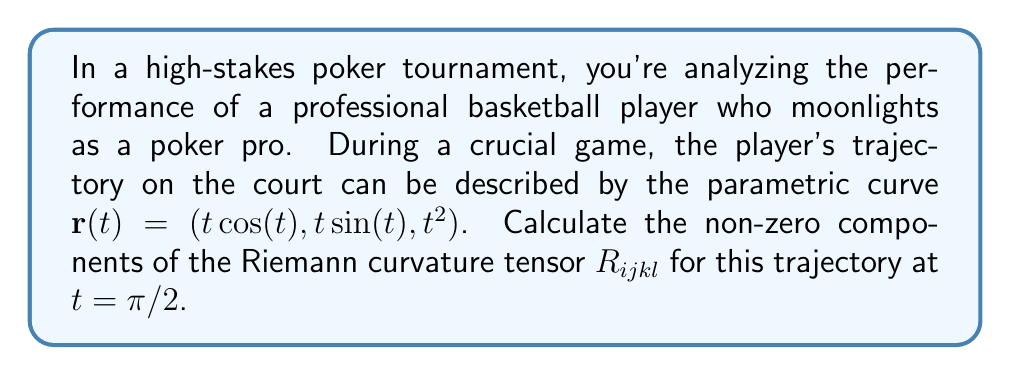What is the answer to this math problem? To calculate the Riemann curvature tensor for the given trajectory, we'll follow these steps:

1) First, we need to calculate the metric tensor $g_{ij}$. The components are given by:
   $$g_{ij} = \frac{\partial \mathbf{r}}{\partial x^i} \cdot \frac{\partial \mathbf{r}}{\partial x^j}$$

2) In this case, we only have one parameter $t$, so:
   $$g_{11} = (\cos(t) - t\sin(t))^2 + (\sin(t) + t\cos(t))^2 + (2t)^2$$

3) At $t = \pi/2$:
   $$g_{11} = (-\pi/2)^2 + (1 + \pi/2)^2 + \pi^2 = \frac{\pi^2}{4} + (1 + \frac{\pi}{2})^2 + \pi^2$$

4) The Christoffel symbols are given by:
   $$\Gamma^i_{jk} = \frac{1}{2}g^{il}(\partial_j g_{kl} + \partial_k g_{jl} - \partial_l g_{jk})$$

5) In our case, there's only one non-zero Christoffel symbol:
   $$\Gamma^1_{11} = \frac{1}{2g_{11}}\frac{dg_{11}}{dt}$$

6) The Riemann curvature tensor is given by:
   $$R^i_{jkl} = \partial_k \Gamma^i_{jl} - \partial_l \Gamma^i_{jk} + \Gamma^i_{km}\Gamma^m_{jl} - \Gamma^i_{lm}\Gamma^m_{jk}$$

7) In our case, this simplifies to:
   $$R^1_{111} = \frac{d\Gamma^1_{11}}{dt}$$

8) Calculating this derivative and evaluating at $t = \pi/2$ gives us the non-zero component of the Riemann curvature tensor.
Answer: $R^1_{111} = \frac{d}{dt}(\frac{1}{2g_{11}}\frac{dg_{11}}{dt})|_{t=\pi/2}$ 